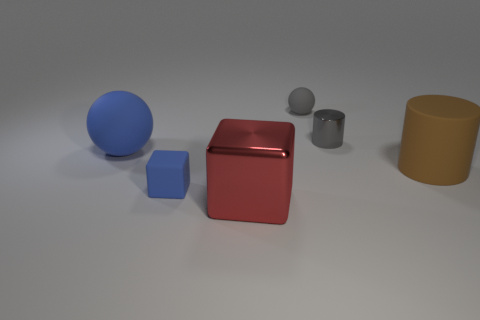Add 4 blue matte balls. How many objects exist? 10 Subtract all gray spheres. How many spheres are left? 1 Subtract all blocks. How many objects are left? 4 Subtract 2 cylinders. How many cylinders are left? 0 Subtract all cyan balls. How many brown cylinders are left? 1 Subtract all small purple metal cylinders. Subtract all large metal objects. How many objects are left? 5 Add 4 big cylinders. How many big cylinders are left? 5 Add 5 brown rubber cylinders. How many brown rubber cylinders exist? 6 Subtract 0 red cylinders. How many objects are left? 6 Subtract all blue blocks. Subtract all blue spheres. How many blocks are left? 1 